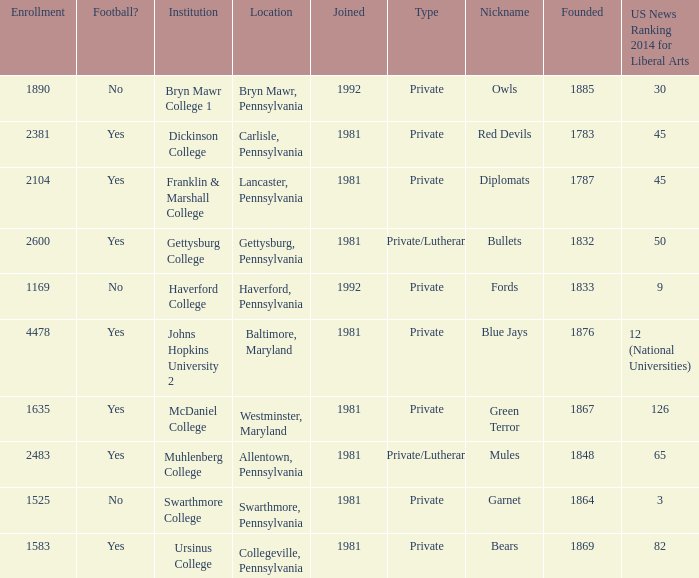When was Dickinson College founded? 1783.0. 